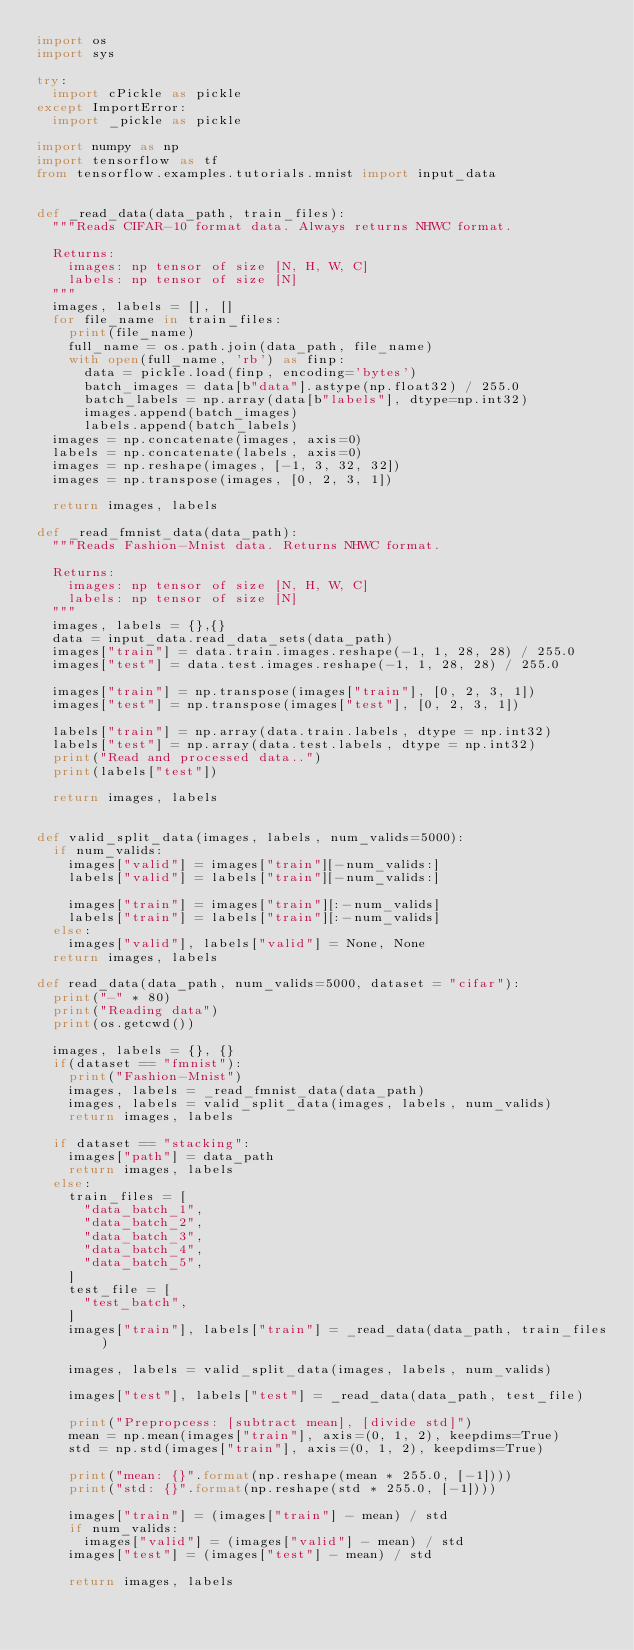Convert code to text. <code><loc_0><loc_0><loc_500><loc_500><_Python_>import os
import sys

try:
  import cPickle as pickle
except ImportError:
  import _pickle as pickle

import numpy as np
import tensorflow as tf
from tensorflow.examples.tutorials.mnist import input_data


def _read_data(data_path, train_files):
  """Reads CIFAR-10 format data. Always returns NHWC format.

  Returns:
    images: np tensor of size [N, H, W, C]
    labels: np tensor of size [N]
  """
  images, labels = [], []
  for file_name in train_files:
    print(file_name)
    full_name = os.path.join(data_path, file_name)
    with open(full_name, 'rb') as finp:
      data = pickle.load(finp, encoding='bytes')
      batch_images = data[b"data"].astype(np.float32) / 255.0
      batch_labels = np.array(data[b"labels"], dtype=np.int32)
      images.append(batch_images)
      labels.append(batch_labels)
  images = np.concatenate(images, axis=0)
  labels = np.concatenate(labels, axis=0)
  images = np.reshape(images, [-1, 3, 32, 32])
  images = np.transpose(images, [0, 2, 3, 1])

  return images, labels

def _read_fmnist_data(data_path):
  """Reads Fashion-Mnist data. Returns NHWC format.

  Returns:
    images: np tensor of size [N, H, W, C]
    labels: np tensor of size [N]
  """
  images, labels = {},{}
  data = input_data.read_data_sets(data_path)
  images["train"] = data.train.images.reshape(-1, 1, 28, 28) / 255.0
  images["test"] = data.test.images.reshape(-1, 1, 28, 28) / 255.0

  images["train"] = np.transpose(images["train"], [0, 2, 3, 1])
  images["test"] = np.transpose(images["test"], [0, 2, 3, 1])

  labels["train"] = np.array(data.train.labels, dtype = np.int32)
  labels["test"] = np.array(data.test.labels, dtype = np.int32)
  print("Read and processed data..")
  print(labels["test"])

  return images, labels


def valid_split_data(images, labels, num_valids=5000):
  if num_valids:
    images["valid"] = images["train"][-num_valids:]
    labels["valid"] = labels["train"][-num_valids:]

    images["train"] = images["train"][:-num_valids]
    labels["train"] = labels["train"][:-num_valids]
  else:
    images["valid"], labels["valid"] = None, None
  return images, labels

def read_data(data_path, num_valids=5000, dataset = "cifar"):
  print("-" * 80)
  print("Reading data")
  print(os.getcwd())

  images, labels = {}, {}
  if(dataset == "fmnist"):
    print("Fashion-Mnist")
    images, labels = _read_fmnist_data(data_path)
    images, labels = valid_split_data(images, labels, num_valids)
    return images, labels

  if dataset == "stacking":
    images["path"] = data_path
    return images, labels
  else:
    train_files = [
      "data_batch_1",
      "data_batch_2",
      "data_batch_3",
      "data_batch_4",
      "data_batch_5",
    ]
    test_file = [
      "test_batch",
    ]
    images["train"], labels["train"] = _read_data(data_path, train_files)

    images, labels = valid_split_data(images, labels, num_valids)

    images["test"], labels["test"] = _read_data(data_path, test_file)

    print("Prepropcess: [subtract mean], [divide std]")
    mean = np.mean(images["train"], axis=(0, 1, 2), keepdims=True)
    std = np.std(images["train"], axis=(0, 1, 2), keepdims=True)

    print("mean: {}".format(np.reshape(mean * 255.0, [-1])))
    print("std: {}".format(np.reshape(std * 255.0, [-1])))

    images["train"] = (images["train"] - mean) / std
    if num_valids:
      images["valid"] = (images["valid"] - mean) / std
    images["test"] = (images["test"] - mean) / std

    return images, labels

</code> 